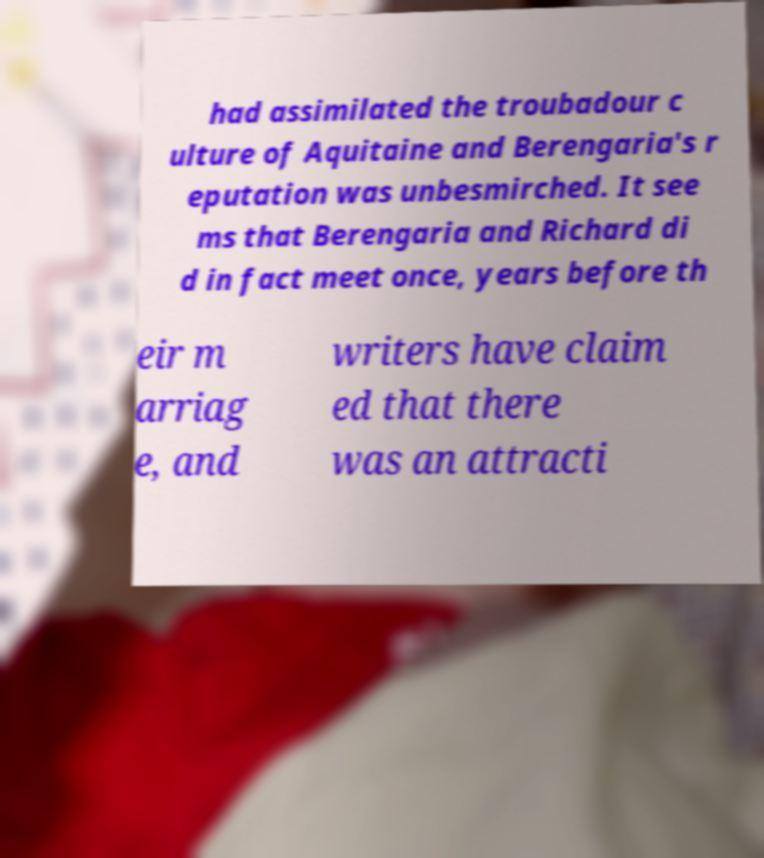Please read and relay the text visible in this image. What does it say? had assimilated the troubadour c ulture of Aquitaine and Berengaria's r eputation was unbesmirched. It see ms that Berengaria and Richard di d in fact meet once, years before th eir m arriag e, and writers have claim ed that there was an attracti 